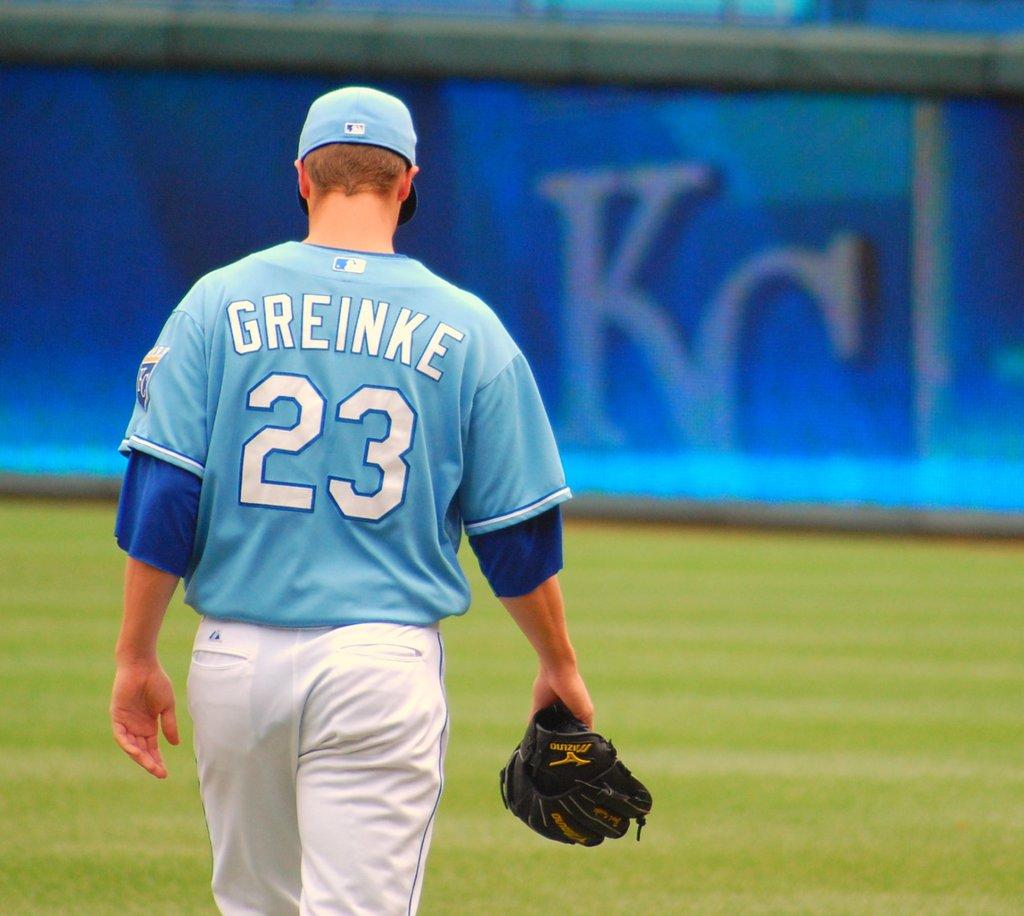What is greinke's number?
Your answer should be compact. 23. What two letters are on the sign in the back?
Your answer should be very brief. Kc. 